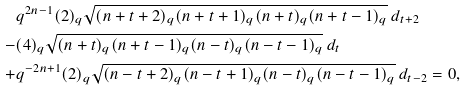Convert formula to latex. <formula><loc_0><loc_0><loc_500><loc_500>& q ^ { 2 n - 1 } ( 2 ) _ { q } \sqrt { ( n + t + 2 ) _ { q } ( n + t + 1 ) _ { q } ( n + t ) _ { q } ( n + t - 1 ) _ { q } } \, d _ { t + 2 } \\ - & ( 4 ) _ { q } \sqrt { ( n + t ) _ { q } ( n + t - 1 ) _ { q } ( n - t ) _ { q } ( n - t - 1 ) _ { q } } \, d _ { t } \\ + & q ^ { - 2 n + 1 } ( 2 ) _ { q } \sqrt { ( n - t + 2 ) _ { q } ( n - t + 1 ) _ { q } ( n - t ) _ { q } ( n - t - 1 ) _ { q } } \, d _ { t - 2 } = 0 ,</formula> 